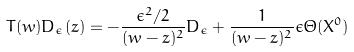Convert formula to latex. <formula><loc_0><loc_0><loc_500><loc_500>T ( w ) D _ { \epsilon } ( z ) = - \frac { \epsilon ^ { 2 } / 2 } { ( w - z ) ^ { 2 } } D _ { \epsilon } + \frac { 1 } { ( w - z ) ^ { 2 } } \epsilon \Theta ( X ^ { 0 } )</formula> 